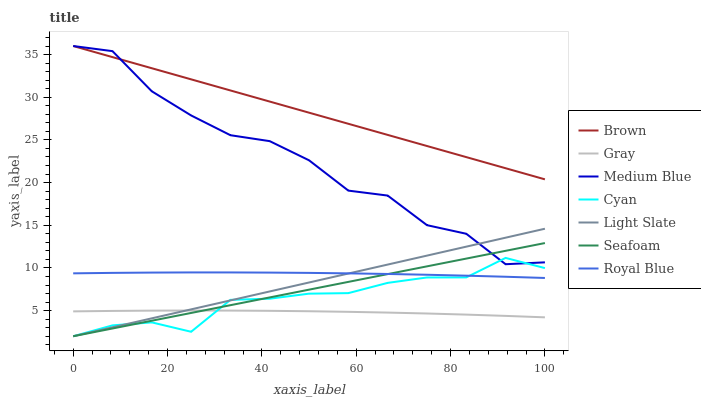Does Gray have the minimum area under the curve?
Answer yes or no. Yes. Does Brown have the maximum area under the curve?
Answer yes or no. Yes. Does Light Slate have the minimum area under the curve?
Answer yes or no. No. Does Light Slate have the maximum area under the curve?
Answer yes or no. No. Is Seafoam the smoothest?
Answer yes or no. Yes. Is Medium Blue the roughest?
Answer yes or no. Yes. Is Gray the smoothest?
Answer yes or no. No. Is Gray the roughest?
Answer yes or no. No. Does Gray have the lowest value?
Answer yes or no. No. Does Medium Blue have the highest value?
Answer yes or no. Yes. Does Light Slate have the highest value?
Answer yes or no. No. Is Light Slate less than Brown?
Answer yes or no. Yes. Is Royal Blue greater than Gray?
Answer yes or no. Yes. Does Light Slate intersect Royal Blue?
Answer yes or no. Yes. Is Light Slate less than Royal Blue?
Answer yes or no. No. Is Light Slate greater than Royal Blue?
Answer yes or no. No. Does Light Slate intersect Brown?
Answer yes or no. No. 